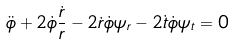<formula> <loc_0><loc_0><loc_500><loc_500>\ddot { \phi } + 2 \dot { \phi } \frac { \dot { r } } { r } - 2 \dot { r } \dot { \phi } \psi _ { r } - 2 \dot { t } \dot { \phi } \psi _ { t } = 0</formula> 